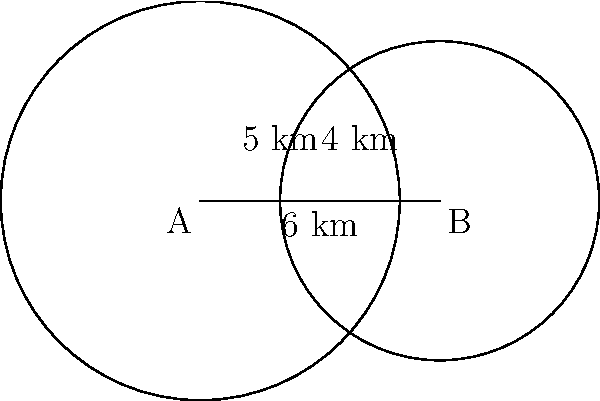Two circular pipeline routes intersect as shown in the diagram. Route A has a radius of 5 km, and Route B has a radius of 4 km. The centers of the routes are 6 km apart. What is the area of the region where the two pipeline routes overlap? (Use $\pi = 3.14$ for calculations) To find the area of overlap between two intersecting circles, we need to follow these steps:

1) First, we need to find the distance from the center of each circle to the line joining the points of intersection. Let's call this distance $h$ for circle A and $k$ for circle B.

2) We can use the Pythagorean theorem to set up an equation:

   $5^2 = h^2 + 3^2$ and $4^2 = k^2 + 3^2$

   This is because the line joining the centers (6 km) is divided into three parts: $h$, $k$, and the remaining middle part.

3) Solving these equations:
   $h = \sqrt{5^2 - 3^2} = 4$ km
   $k = \sqrt{4^2 - 3^2} = \sqrt{7}$ km

4) Now, we can calculate the area of the circular sector in each circle:
   
   For circle A: $\theta_A = 2 \arccos(\frac{h}{5}) = 2 \arccos(0.8)$
   Area of sector A = $\frac{1}{2} \cdot 5^2 \cdot \theta_A$

   For circle B: $\theta_B = 2 \arccos(\frac{k}{4}) = 2 \arccos(\frac{\sqrt{7}}{4})$
   Area of sector B = $\frac{1}{2} \cdot 4^2 \cdot \theta_B$

5) The area of the triangle formed in each circle:
   
   Triangle A area = $\frac{1}{2} \cdot 3 \cdot 4 = 6$ km²
   Triangle B area = $\frac{1}{2} \cdot 3 \cdot \sqrt{7} = \frac{3\sqrt{7}}{2}$ km²

6) The overlap area is the sum of the two sectors minus the sum of the two triangles:

   Overlap Area = (Area of sector A + Area of sector B) - (Triangle A area + Triangle B area)

7) Calculating with $\pi = 3.14$:
   
   Overlap Area = $(12.5 \cdot 2.2143 + 8 \cdot 2.4980) - (6 + \frac{3\sqrt{7}}{2})$
                = $27.6788 + 19.9840 - (6 + 3.9686)$
                = $37.6942$ km²
Answer: 37.69 km² 